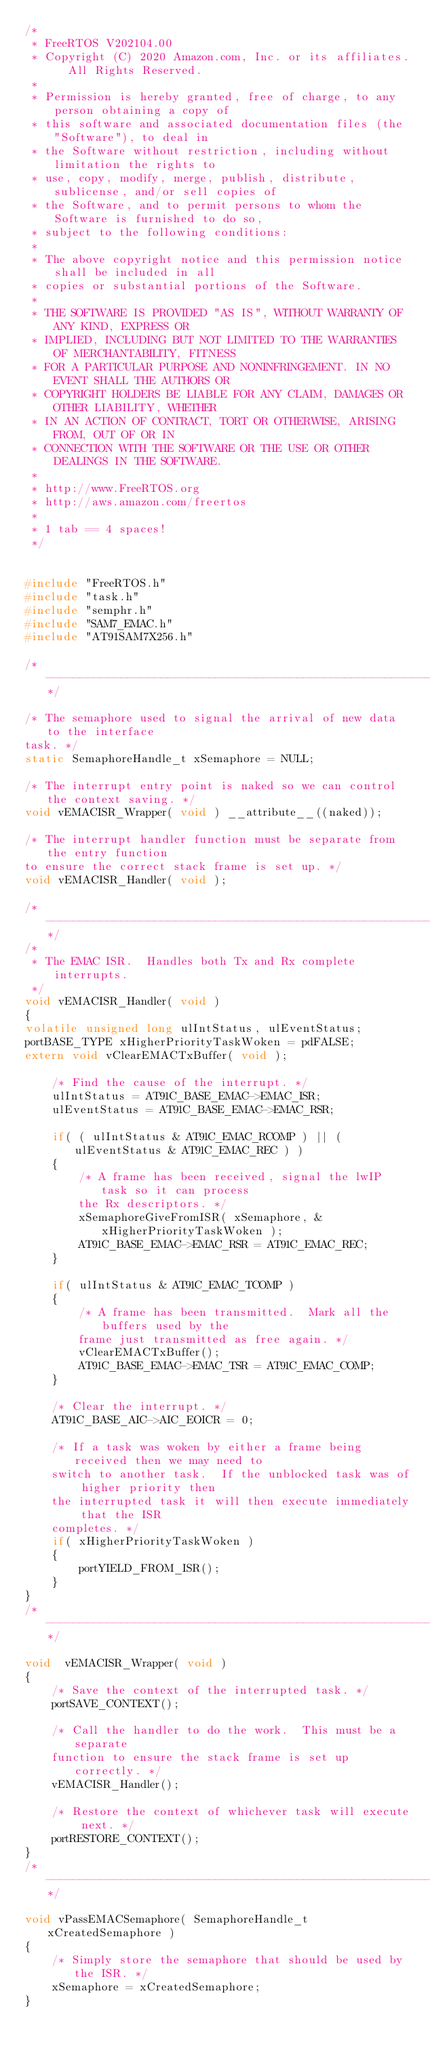Convert code to text. <code><loc_0><loc_0><loc_500><loc_500><_C_>/*
 * FreeRTOS V202104.00
 * Copyright (C) 2020 Amazon.com, Inc. or its affiliates.  All Rights Reserved.
 *
 * Permission is hereby granted, free of charge, to any person obtaining a copy of
 * this software and associated documentation files (the "Software"), to deal in
 * the Software without restriction, including without limitation the rights to
 * use, copy, modify, merge, publish, distribute, sublicense, and/or sell copies of
 * the Software, and to permit persons to whom the Software is furnished to do so,
 * subject to the following conditions:
 *
 * The above copyright notice and this permission notice shall be included in all
 * copies or substantial portions of the Software.
 *
 * THE SOFTWARE IS PROVIDED "AS IS", WITHOUT WARRANTY OF ANY KIND, EXPRESS OR
 * IMPLIED, INCLUDING BUT NOT LIMITED TO THE WARRANTIES OF MERCHANTABILITY, FITNESS
 * FOR A PARTICULAR PURPOSE AND NONINFRINGEMENT. IN NO EVENT SHALL THE AUTHORS OR
 * COPYRIGHT HOLDERS BE LIABLE FOR ANY CLAIM, DAMAGES OR OTHER LIABILITY, WHETHER
 * IN AN ACTION OF CONTRACT, TORT OR OTHERWISE, ARISING FROM, OUT OF OR IN
 * CONNECTION WITH THE SOFTWARE OR THE USE OR OTHER DEALINGS IN THE SOFTWARE.
 *
 * http://www.FreeRTOS.org
 * http://aws.amazon.com/freertos
 *
 * 1 tab == 4 spaces!
 */


#include "FreeRTOS.h"
#include "task.h"
#include "semphr.h"
#include "SAM7_EMAC.h"
#include "AT91SAM7X256.h"

/*-----------------------------------------------------------*/

/* The semaphore used to signal the arrival of new data to the interface
task. */
static SemaphoreHandle_t xSemaphore = NULL;

/* The interrupt entry point is naked so we can control the context saving. */
void vEMACISR_Wrapper( void ) __attribute__((naked));

/* The interrupt handler function must be separate from the entry function
to ensure the correct stack frame is set up. */
void vEMACISR_Handler( void );

/*-----------------------------------------------------------*/
/*
 * The EMAC ISR.  Handles both Tx and Rx complete interrupts.
 */
void vEMACISR_Handler( void )
{
volatile unsigned long ulIntStatus, ulEventStatus;
portBASE_TYPE xHigherPriorityTaskWoken = pdFALSE;
extern void vClearEMACTxBuffer( void );

	/* Find the cause of the interrupt. */
	ulIntStatus = AT91C_BASE_EMAC->EMAC_ISR;
	ulEventStatus = AT91C_BASE_EMAC->EMAC_RSR;

	if( ( ulIntStatus & AT91C_EMAC_RCOMP ) || ( ulEventStatus & AT91C_EMAC_REC ) )
	{
		/* A frame has been received, signal the lwIP task so it can process
		the Rx descriptors. */
		xSemaphoreGiveFromISR( xSemaphore, &xHigherPriorityTaskWoken );
		AT91C_BASE_EMAC->EMAC_RSR = AT91C_EMAC_REC;
	}

	if( ulIntStatus & AT91C_EMAC_TCOMP )
	{
		/* A frame has been transmitted.  Mark all the buffers used by the
		frame just transmitted as free again. */
		vClearEMACTxBuffer();
		AT91C_BASE_EMAC->EMAC_TSR = AT91C_EMAC_COMP;
	}

	/* Clear the interrupt. */
	AT91C_BASE_AIC->AIC_EOICR = 0;

	/* If a task was woken by either a frame being received then we may need to 
	switch to another task.  If the unblocked task was of higher priority then
	the interrupted task it will then execute immediately that the ISR
	completes. */
	if( xHigherPriorityTaskWoken )
	{
		portYIELD_FROM_ISR();
	}
}
/*-----------------------------------------------------------*/

void  vEMACISR_Wrapper( void )
{
	/* Save the context of the interrupted task. */
	portSAVE_CONTEXT();

	/* Call the handler to do the work.  This must be a separate
	function to ensure the stack frame is set up correctly. */
	vEMACISR_Handler();

	/* Restore the context of whichever task will execute next. */
	portRESTORE_CONTEXT();
}
/*-----------------------------------------------------------*/

void vPassEMACSemaphore( SemaphoreHandle_t xCreatedSemaphore )
{
	/* Simply store the semaphore that should be used by the ISR. */
	xSemaphore = xCreatedSemaphore;
}

</code> 